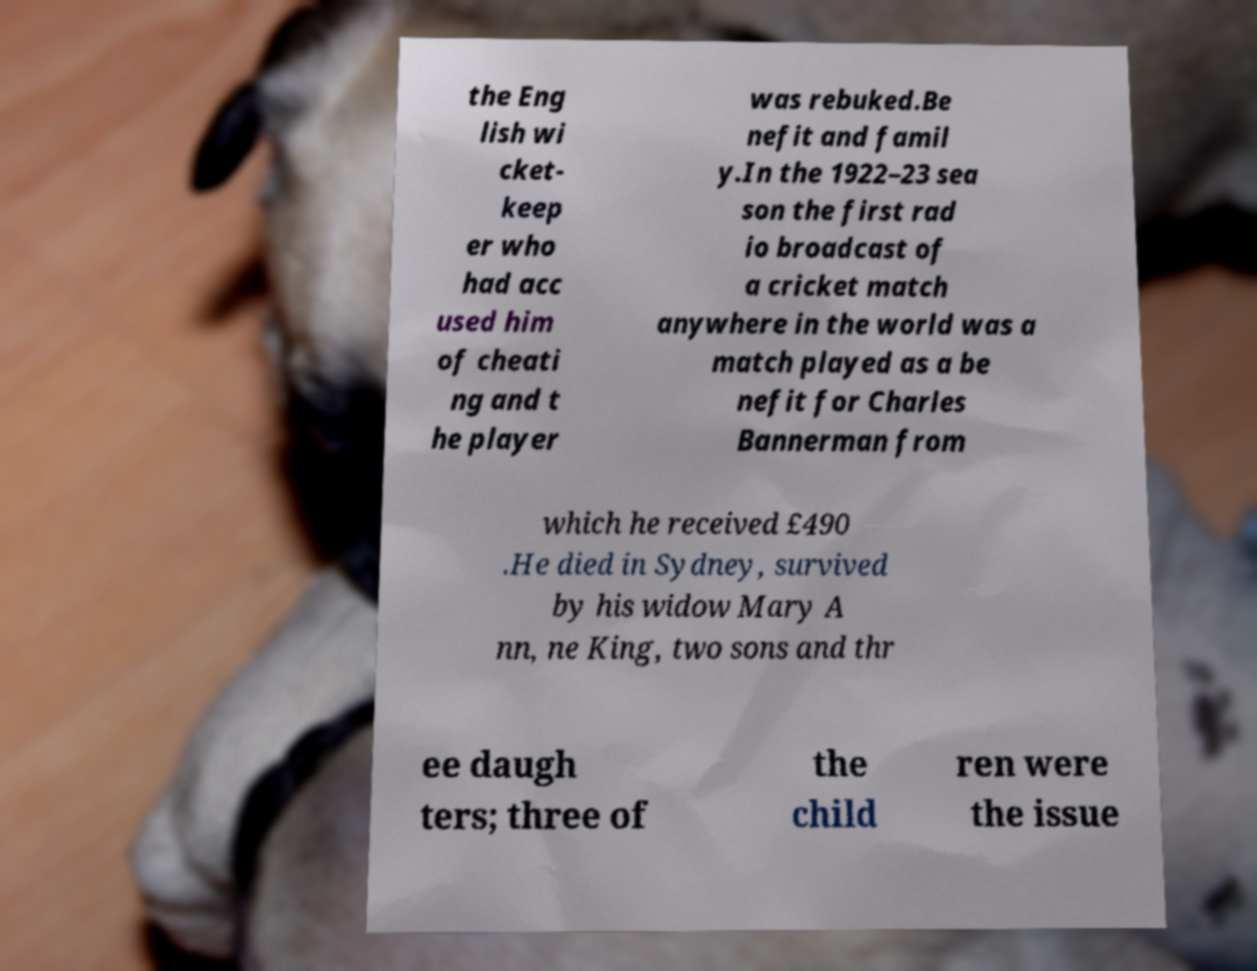Could you assist in decoding the text presented in this image and type it out clearly? the Eng lish wi cket- keep er who had acc used him of cheati ng and t he player was rebuked.Be nefit and famil y.In the 1922–23 sea son the first rad io broadcast of a cricket match anywhere in the world was a match played as a be nefit for Charles Bannerman from which he received £490 .He died in Sydney, survived by his widow Mary A nn, ne King, two sons and thr ee daugh ters; three of the child ren were the issue 